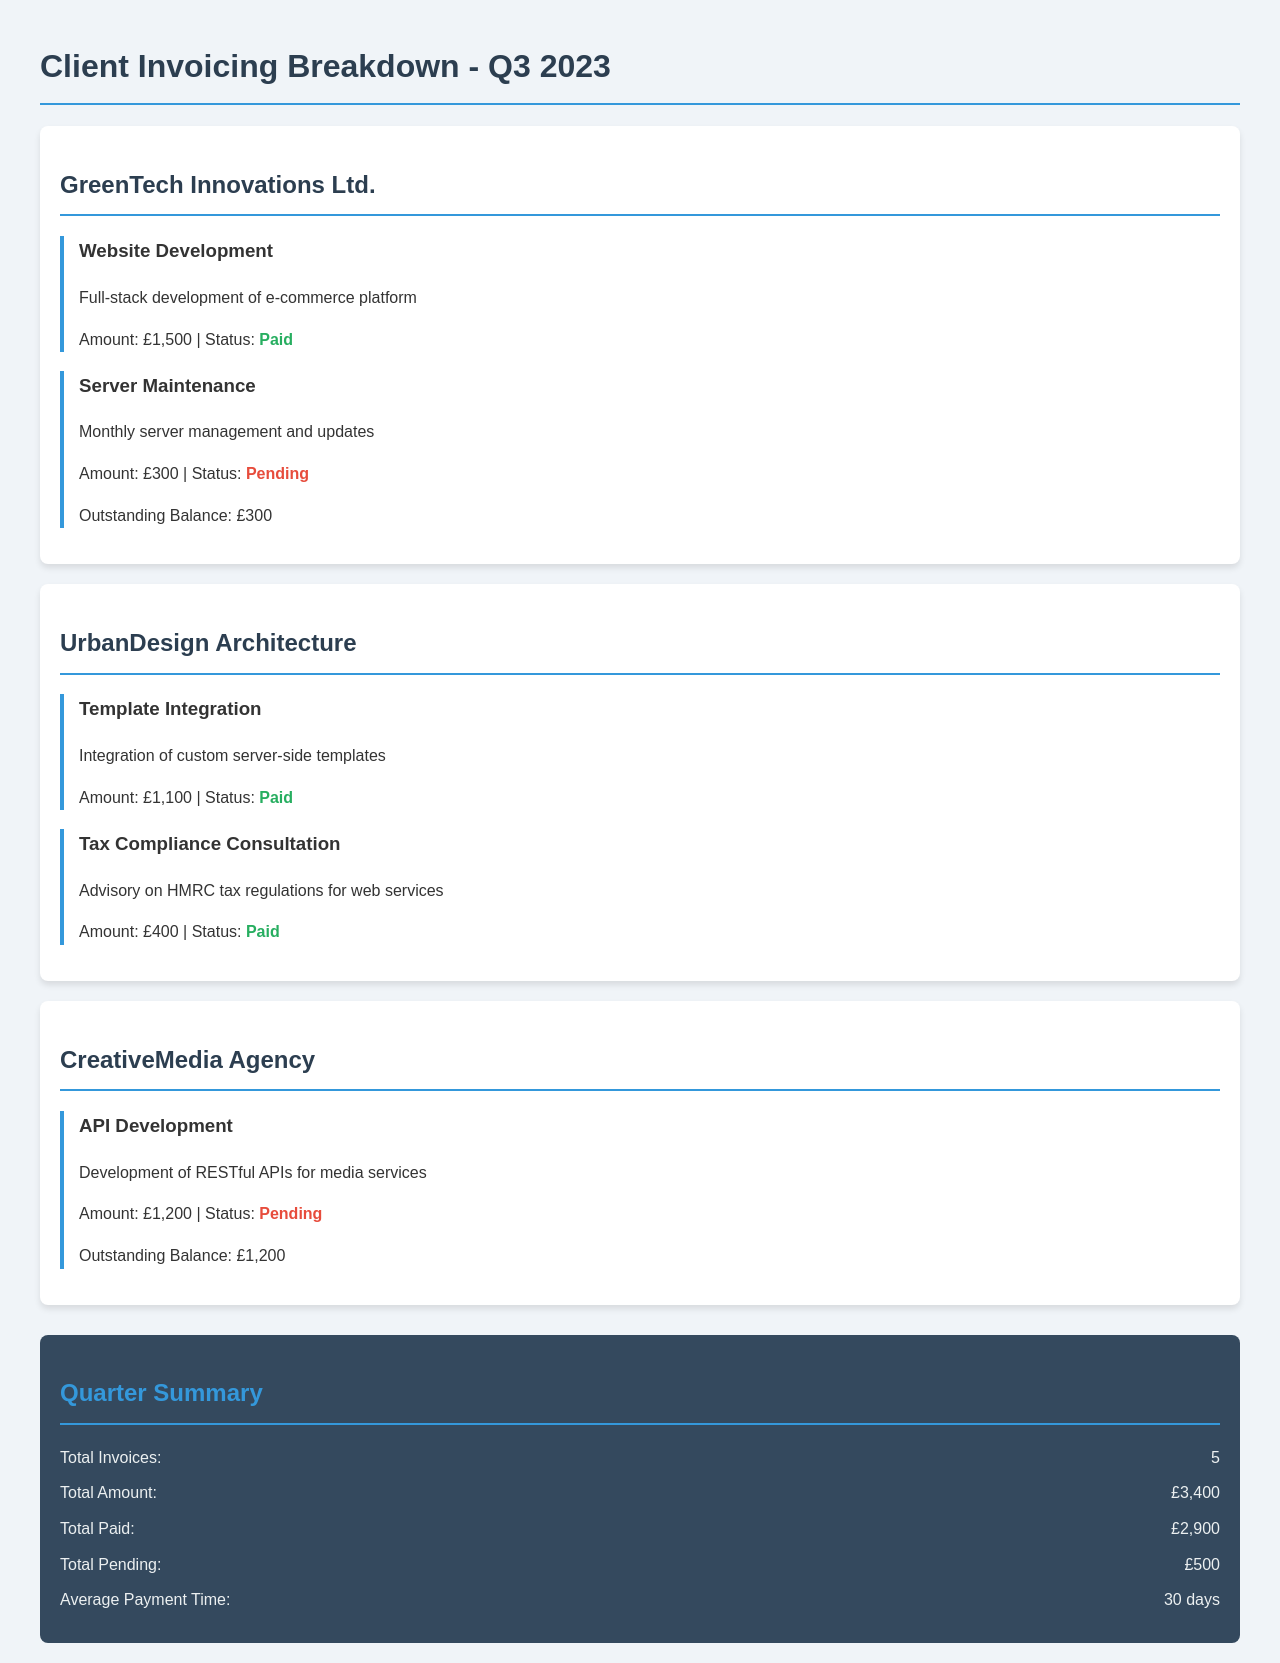What is the total number of invoices? The total number of invoices is mentioned in the quarter summary section of the document.
Answer: 5 What is the total amount billed? The total amount billed is specified under the quarter summary section.
Answer: £3,400 Which client has a pending payment? The clients with pending payments are listed with their services and statuses in the document.
Answer: GreenTech Innovations Ltd., CreativeMedia Agency What is the outstanding balance for CreativeMedia Agency? The outstanding balance for each client is stated under their respective service items.
Answer: £1,200 What service did GreenTech Innovations Ltd. pay for? The paid services for each client are highlighted in the document along with their status.
Answer: Website Development Which service amounts to £400? The specific services and their corresponding amounts are detailed within the client cards.
Answer: Tax Compliance Consultation What is the average payment time? The average payment time is indicated in the quarter summary section of the document.
Answer: 30 days How many services rendered to UrbanDesign Architecture are paid? The number of paid services for UrbanDesign Architecture can be counted from the client card.
Answer: 2 